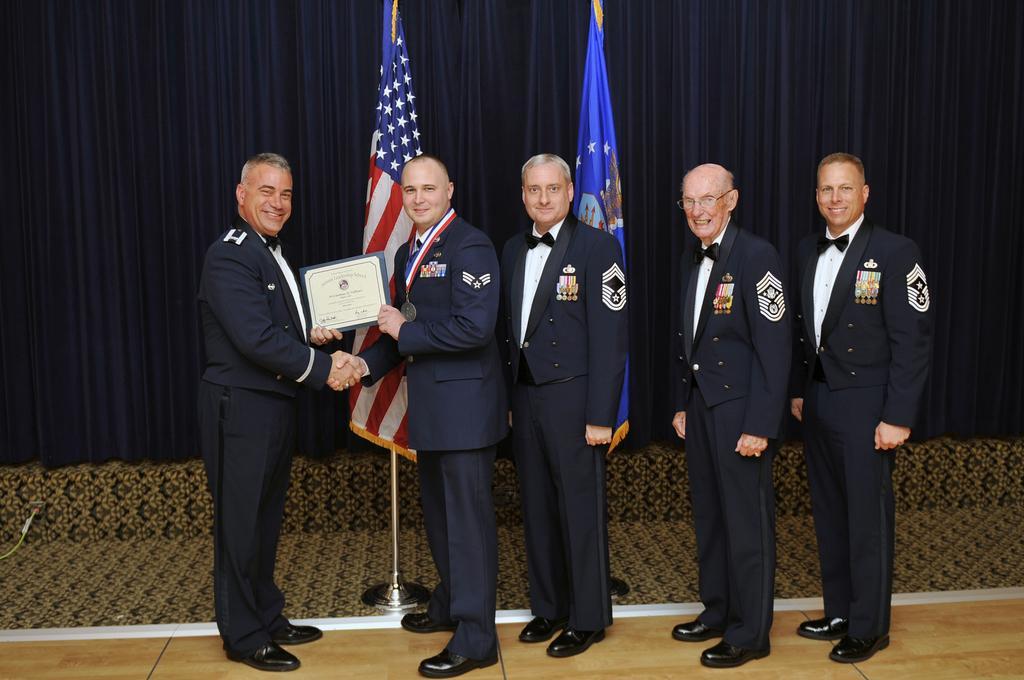In one or two sentences, can you explain what this image depicts? In this image I can see the group of people standing and wearing the uniforms. I can see two people are holding the frame. In the back there are two flags can be seen. In the background I can see the navy blue color curtain. 